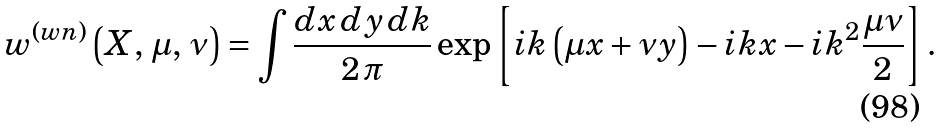<formula> <loc_0><loc_0><loc_500><loc_500>w ^ { ( w n ) } \left ( X , \, \mu , \, \nu \right ) = \int \frac { d x \, d y \, d k } { 2 \, \pi } \exp \left [ i k \left ( \mu x + \nu y \right ) - i k x - i k ^ { 2 } \frac { \mu \nu } { 2 } \right ] .</formula> 